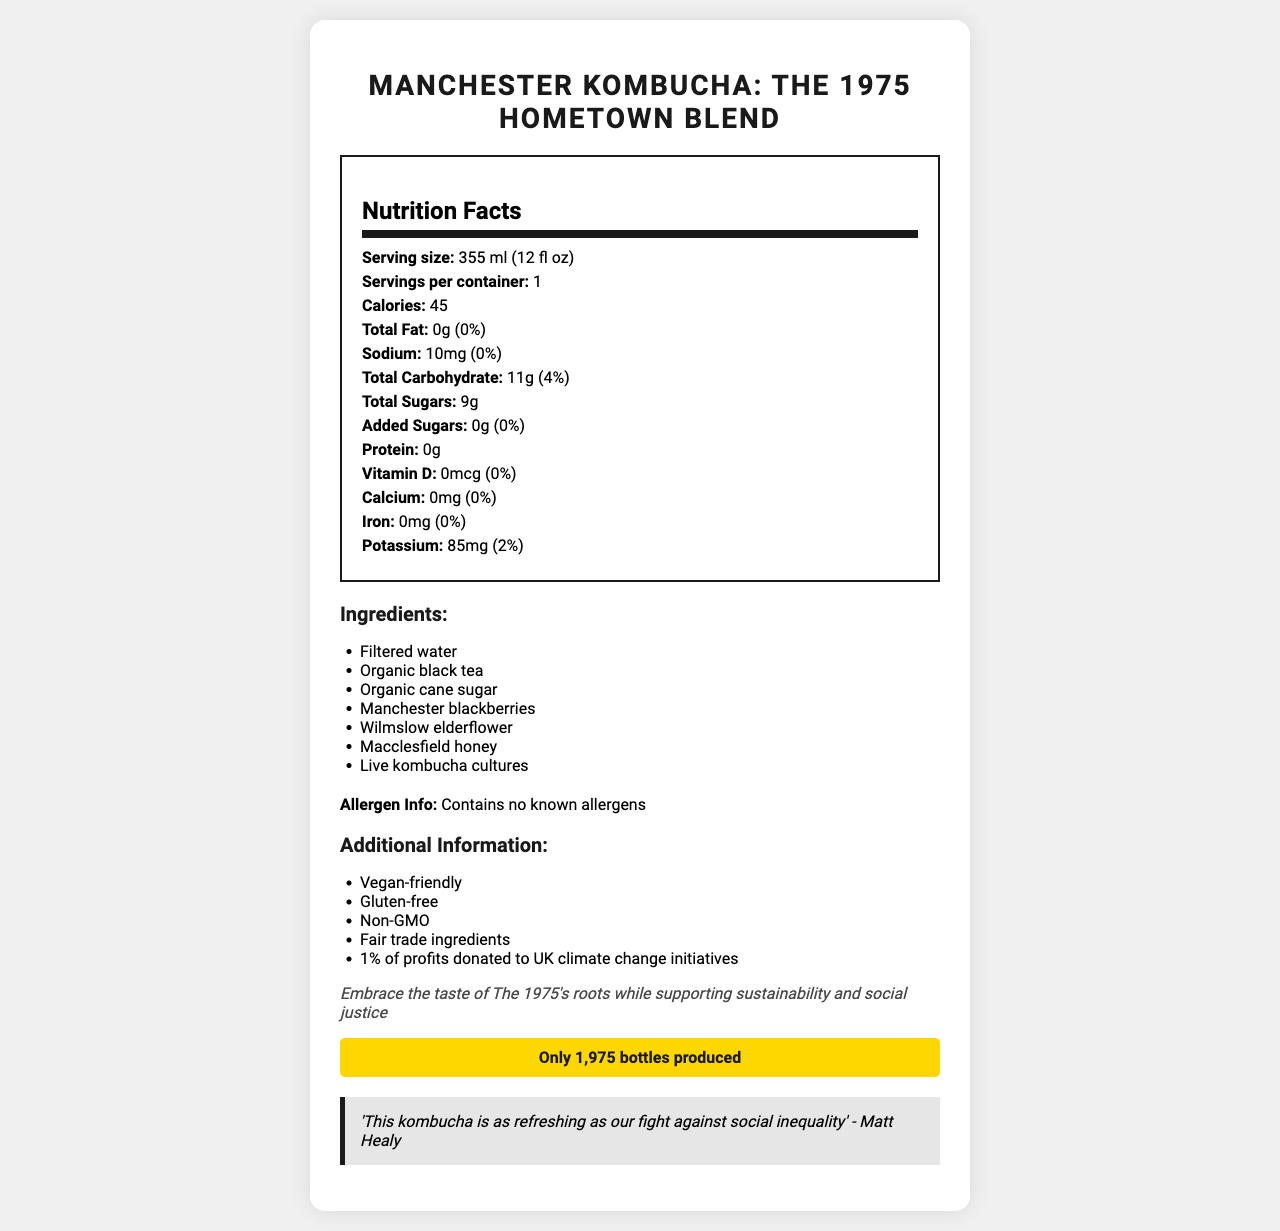who is quoted in the document? The document features a quote by Matt Healy who is mentioned explicitly in the highlighted quote section at the bottom.
Answer: Matt Healy what is the serving size for Manchester Kombucha: The 1975 Hometown Blend? The serving size is mentioned at the top of the nutrition facts section.
Answer: 355 ml (12 fl oz) how many servings per container are there? The servings per container are clearly stated as 1 in the nutrition facts section.
Answer: 1 what is the total amount of sugars in the kombucha? The total amount of sugars is shown in the nutrition facts section under 'Total Sugars'.
Answer: 9g does the product contain any allergens? The allergen information section explicitly states that the product "Contains no known allergens."
Answer: Contains no known allergens is this product vegan-friendly? One of the points in the additional information section confirms that the product is "Vegan-friendly."
Answer: Yes what is the total carbohydrate content and its daily value percentage? The nutrition facts section lists the total carbohydrate content as 11g and its daily value as 4%.
Answer: 11g (4%) what do 1% of the profits go towards? The additional information section states that 1% of profits are donated to UK climate change initiatives.
Answer: UK climate change initiatives who was involved in blending ingredients from the band's hometowns? This detail cannot be determined explicitly from the given document. It mentions ingredients from the band's hometowns but does not specify who blended them.
Answer: The 1975 which of the following ingredients is not listed in the document? A. Macclesfield honey B. Wilmslow elderflower C. York peppermint D. Manchester blackberries The document lists Macclesfield honey, Wilmslow elderflower, and Manchester blackberries as ingredients but does not mention York peppermint.
Answer: C how many calories are in a single serving? The document specifies that there are 45 calories per serving in the nutrition facts section.
Answer: 45 what is the sodium content in the kombucha? A. 0mg B. 10mg C. 50mg D. 100mg According to the nutrition facts section, the sodium content is 10mg.
Answer: B does the product contain any added sugars? The nutrition facts section lists the amount of added sugars as 0g.
Answer: No what does the brand statement emphasize? The brand statement is clearly stated towards the end of the document and emphasizes the combination of flavor, sustainability, and social justice.
Answer: Embracing the taste of The 1975's roots while supporting sustainability and social justice is this Limited Edition Kombucha gluten-free? The additional information section clearly states that the product is "Gluten-free."
Answer: Yes describe the main idea of the document The main idea of the document is to present comprehensive nutritional information and other relevant details about the "Manchester Kombucha: The 1975 Hometown Blend," emphasizing its unique ingredients tied to The 1975’s origins, social and environmental responsibility, and its limited edition nature.
Answer: The document provides a detailed nutritional breakdown, ingredient list, allergen information, and additional facts about a limited-edition kombucha called "Manchester Kombucha: The 1975 Hometown Blend." It highlights the product's connection to The 1975’s hometowns with special ingredients, emphasizes its vegan, gluten-free, and non-GMO nature, and indicates that 1% of the profits are donated to UK climate change initiatives. It also includes a brand statement about supporting sustainability and social justice and features a quote from Matt Healy. Only 1,975 bottles have been produced. what is the potassium content and its daily value percentage? The potassium content of 85mg and daily value percentage of 2% are listed in the nutrition facts section.
Answer: 85mg (2%) how much organic cane sugar is in the ingredient list? The ingredient list mentions "Organic cane sugar" but does not specify the amount used.
Answer: Cannot be determined 